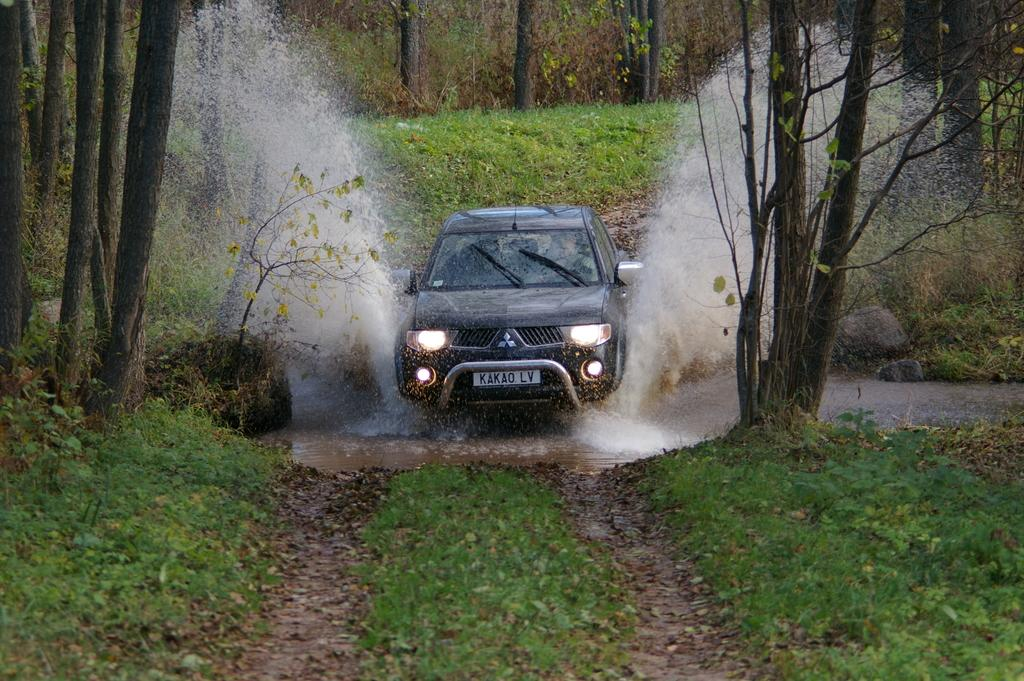What is the main subject in the center of the image? There is a car in the center of the image. What can be seen in the background of the image? There are trees in the background of the image. What type of terrain is visible at the bottom of the image? There is grass at the bottom of the image. What else is present in the image besides the car? Water is visible in the image. What type of loaf is being used to wash the car in the image? There is no loaf present in the image, and the car is not being washed. 